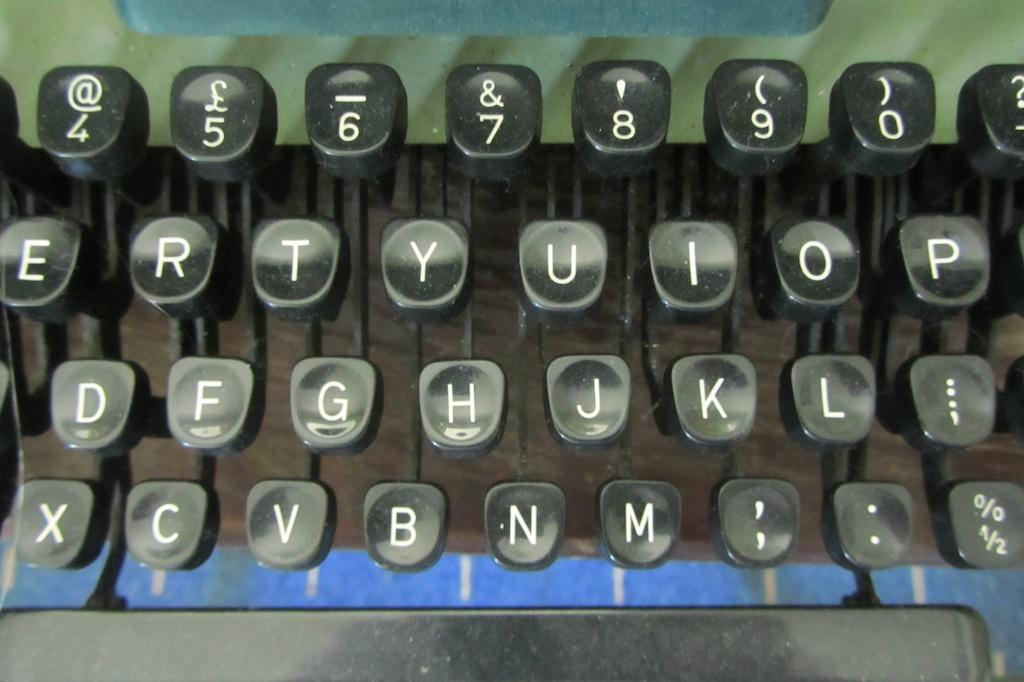<image>
Offer a succinct explanation of the picture presented. A close up of some keys on an old typewriter some that are showing are R, T, Y,  and U. 